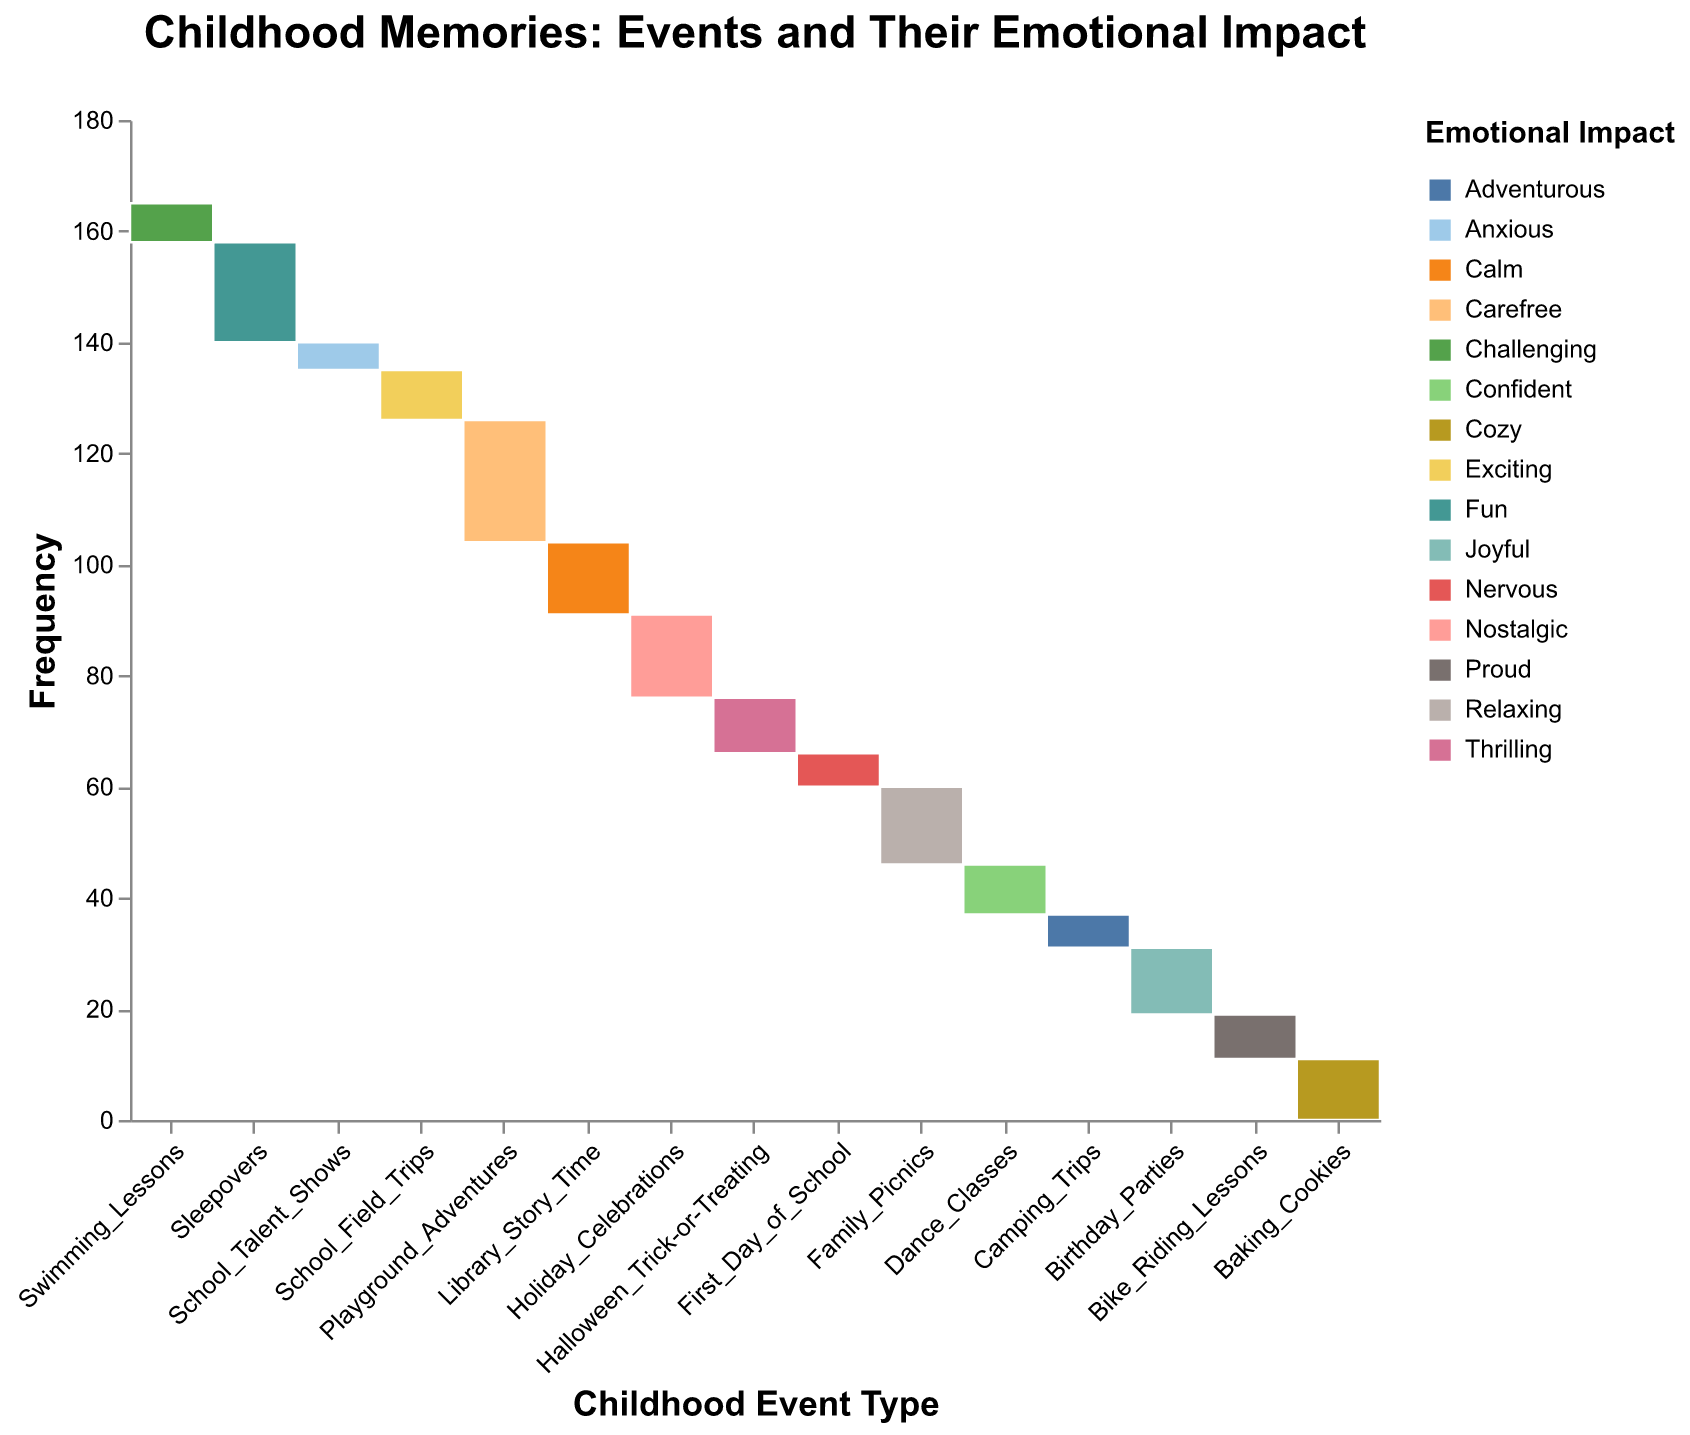Which childhood event has the highest frequency? To find the childhood event with the highest frequency, look at the y-axis and find the event with the tallest bar.
Answer: Playground Adventures Which emotional impact is most frequently associated with Family Picnics? Check the color corresponding to Family Picnics on the plot and refer to the legend to determine the emotional impact.
Answer: Relaxing What is the combined frequency of Sleepovers and Playground Adventures? Add the frequency of Sleepovers (18) to the frequency of Playground Adventures (22).
Answer: 40 Which event type has the lowest frequency? Identify the shortest bar on the y-axis to find the event with the lowest frequency.
Answer: School Talent Shows How does the frequency of Halloween Trick-or-Treating compare to that of Swimming Lessons? Check the heights of the bars for Halloween Trick-or-Treating and Swimming Lessons and compare them.
Answer: Higher How many events are classified with a joyful emotional impact? Look at the plot and count the number of events colored to represent Joyful in the legend.
Answer: 1 Which event has the same frequency as Dance Classes? Compare the height of the bars for each event and find the one that matches the bar height of Dance Classes.
Answer: School Field Trips What percentage of childhood memories related to Baking Cookies are Cozy? Identify the bar section for Baking Cookies, note its height compared to the total height, and refer to the tooltip for the exact value.
Answer: 100% Which event type is associated with the most diverse emotional impacts? Look for an event with multiple different color sections in its bar, representing different emotional impacts.
Answer: Family Picnics Which event has a lower frequency, Bike Riding Lessons or Camping Trips? Compare the heights of the bars for Bike Riding Lessons and Camping Trips.
Answer: Camping Trips 